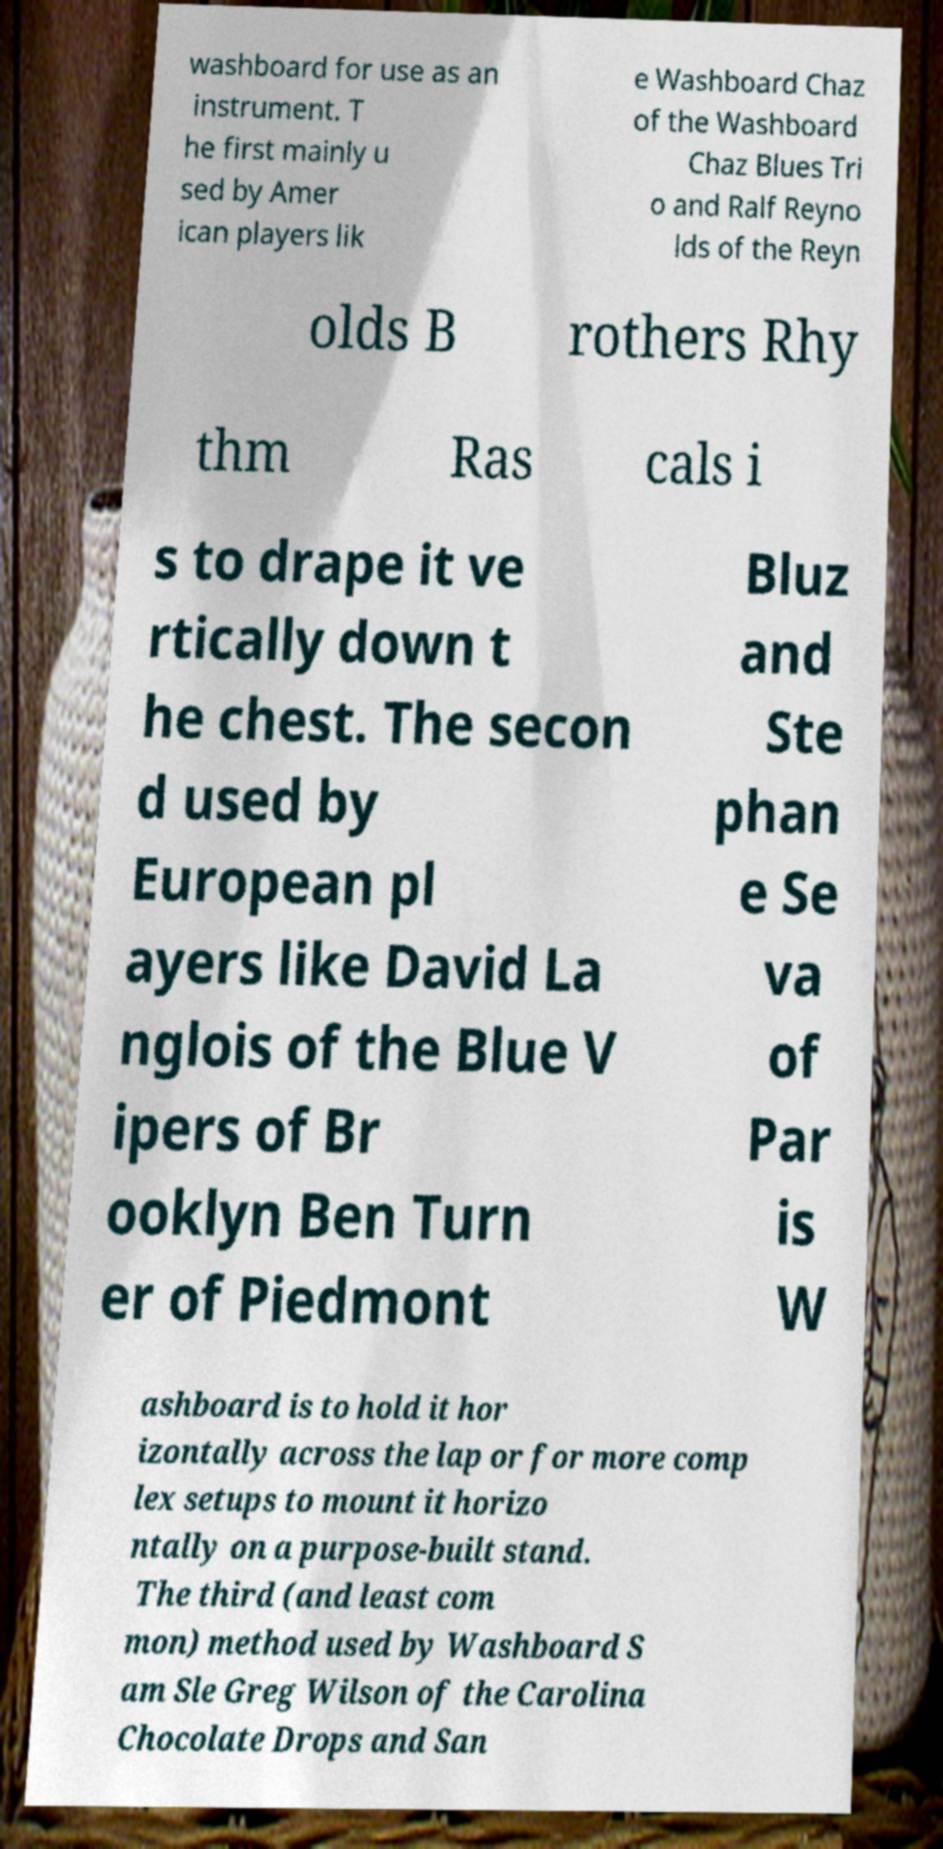Can you accurately transcribe the text from the provided image for me? washboard for use as an instrument. T he first mainly u sed by Amer ican players lik e Washboard Chaz of the Washboard Chaz Blues Tri o and Ralf Reyno lds of the Reyn olds B rothers Rhy thm Ras cals i s to drape it ve rtically down t he chest. The secon d used by European pl ayers like David La nglois of the Blue V ipers of Br ooklyn Ben Turn er of Piedmont Bluz and Ste phan e Se va of Par is W ashboard is to hold it hor izontally across the lap or for more comp lex setups to mount it horizo ntally on a purpose-built stand. The third (and least com mon) method used by Washboard S am Sle Greg Wilson of the Carolina Chocolate Drops and San 